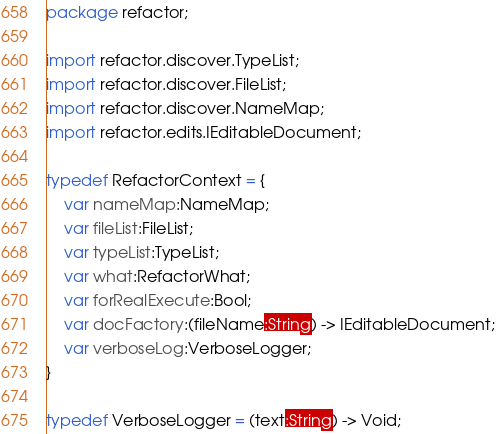Convert code to text. <code><loc_0><loc_0><loc_500><loc_500><_Haxe_>package refactor;

import refactor.discover.TypeList;
import refactor.discover.FileList;
import refactor.discover.NameMap;
import refactor.edits.IEditableDocument;

typedef RefactorContext = {
	var nameMap:NameMap;
	var fileList:FileList;
	var typeList:TypeList;
	var what:RefactorWhat;
	var forRealExecute:Bool;
	var docFactory:(fileName:String) -> IEditableDocument;
	var verboseLog:VerboseLogger;
}

typedef VerboseLogger = (text:String) -> Void;
</code> 